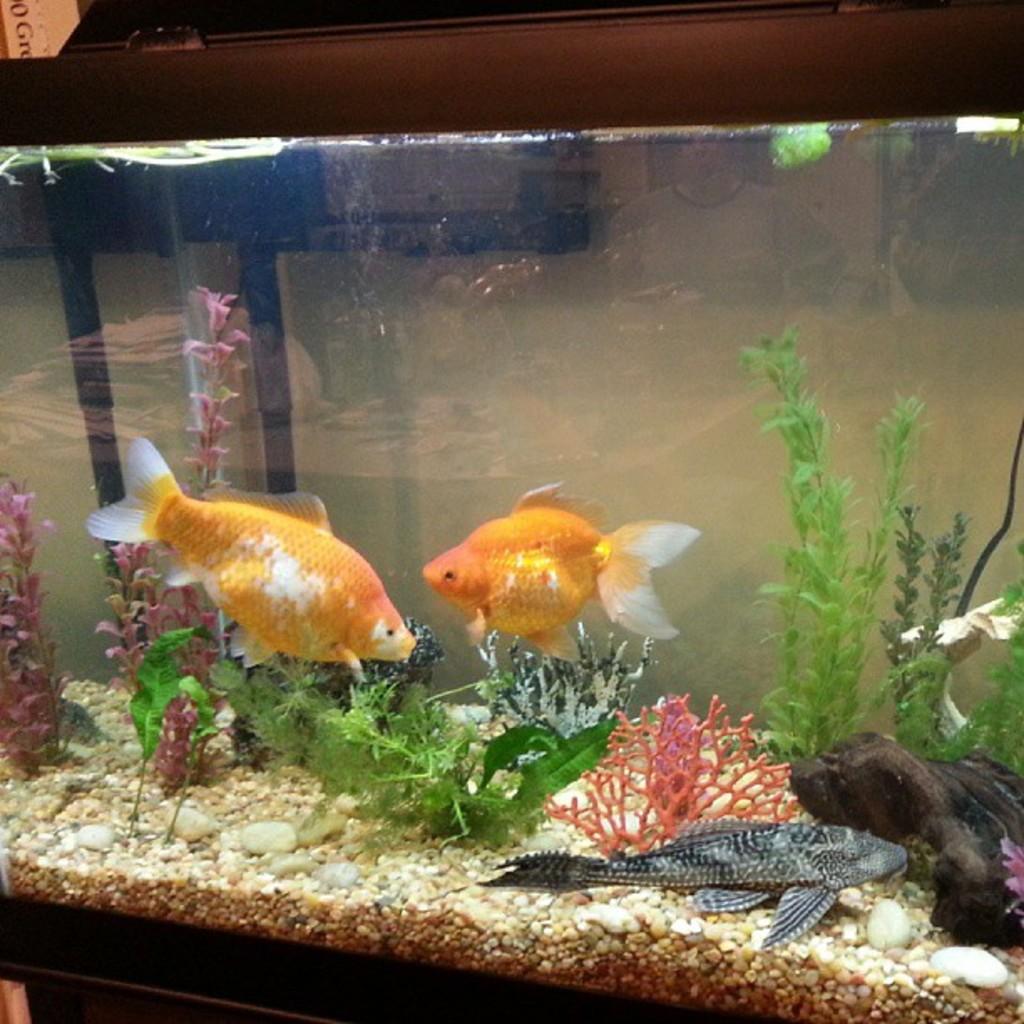Can you describe this image briefly? In the center of this picture we can see an aquarium containing fishes, plants and some other objects. In the background we can see the wall and some other objects. 